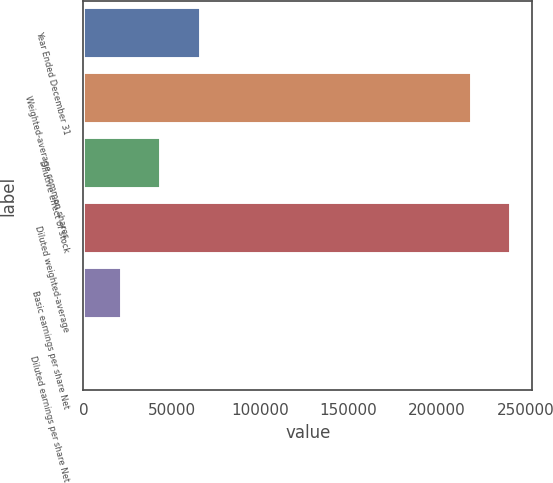Convert chart. <chart><loc_0><loc_0><loc_500><loc_500><bar_chart><fcel>Year Ended December 31<fcel>Weighted-average common shares<fcel>Dilutive effect of stock<fcel>Diluted weighted-average<fcel>Basic earnings per share Net<fcel>Diluted earnings per share Net<nl><fcel>66283.8<fcel>219638<fcel>44189.9<fcel>241732<fcel>22096<fcel>2.14<nl></chart> 